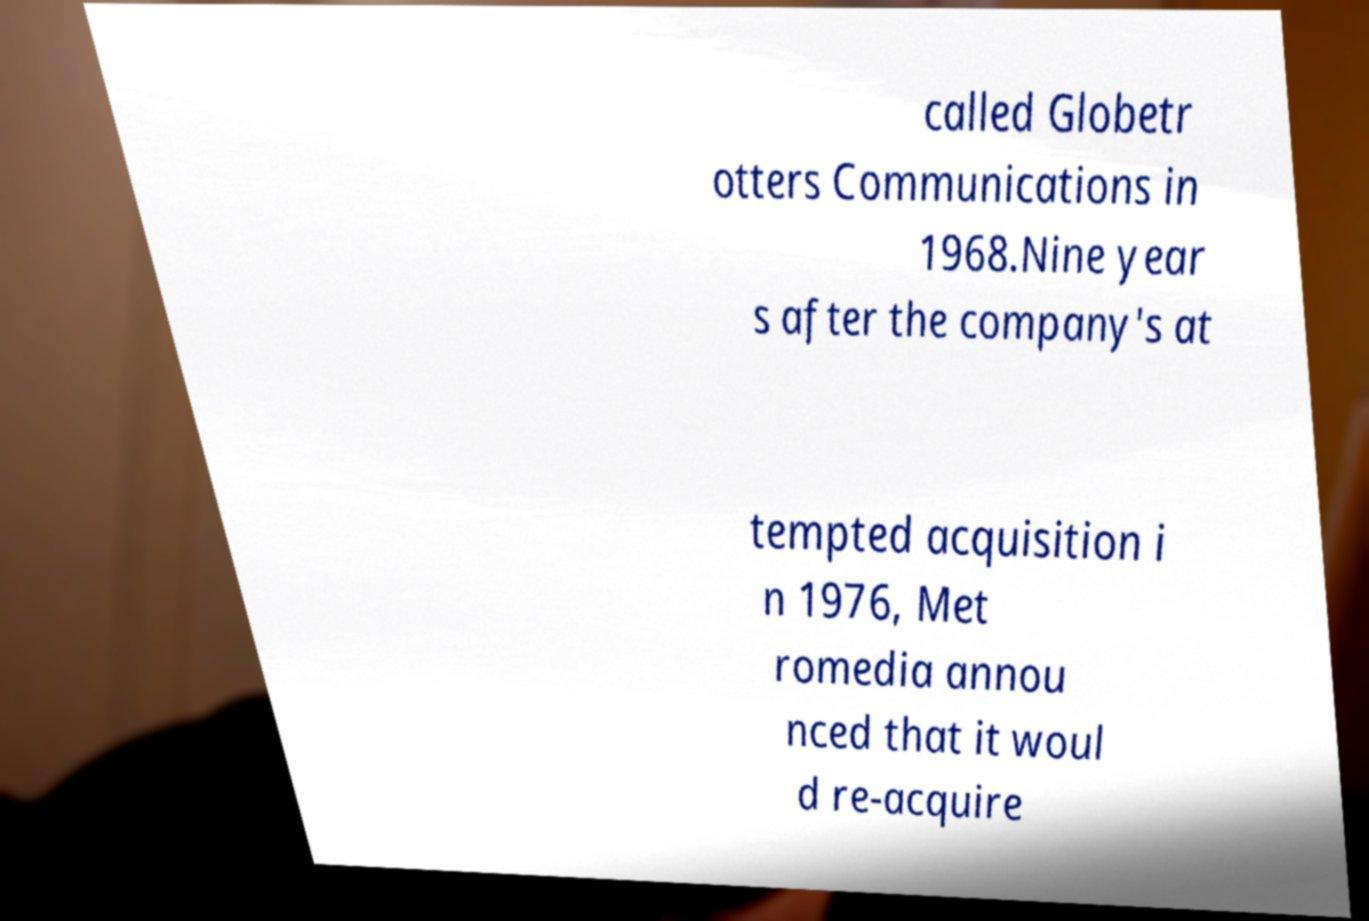For documentation purposes, I need the text within this image transcribed. Could you provide that? called Globetr otters Communications in 1968.Nine year s after the company's at tempted acquisition i n 1976, Met romedia annou nced that it woul d re-acquire 